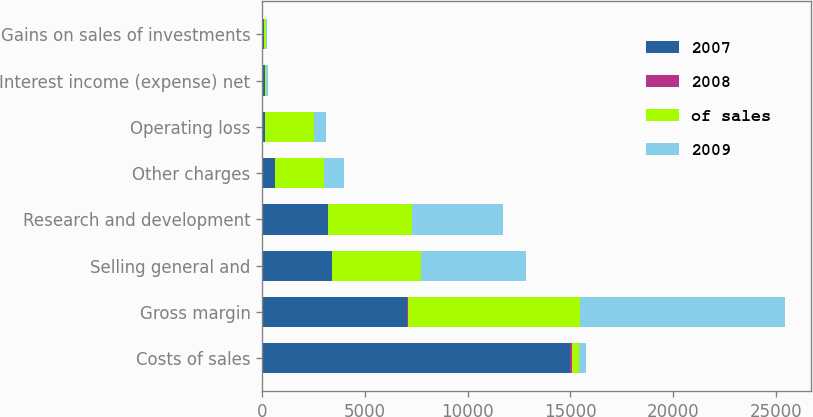Convert chart. <chart><loc_0><loc_0><loc_500><loc_500><stacked_bar_chart><ecel><fcel>Costs of sales<fcel>Gross margin<fcel>Selling general and<fcel>Research and development<fcel>Other charges<fcel>Operating loss<fcel>Interest income (expense) net<fcel>Gains on sales of investments<nl><fcel>2007<fcel>14987<fcel>7057<fcel>3381<fcel>3183<fcel>641<fcel>148<fcel>132<fcel>88<nl><fcel>2008<fcel>68<fcel>32<fcel>15.3<fcel>14.4<fcel>3<fcel>0.7<fcel>0.6<fcel>0.4<nl><fcel>of sales<fcel>350.5<fcel>8395<fcel>4330<fcel>4109<fcel>2347<fcel>2391<fcel>48<fcel>82<nl><fcel>2009<fcel>350.5<fcel>9952<fcel>5092<fcel>4429<fcel>984<fcel>553<fcel>91<fcel>50<nl></chart> 